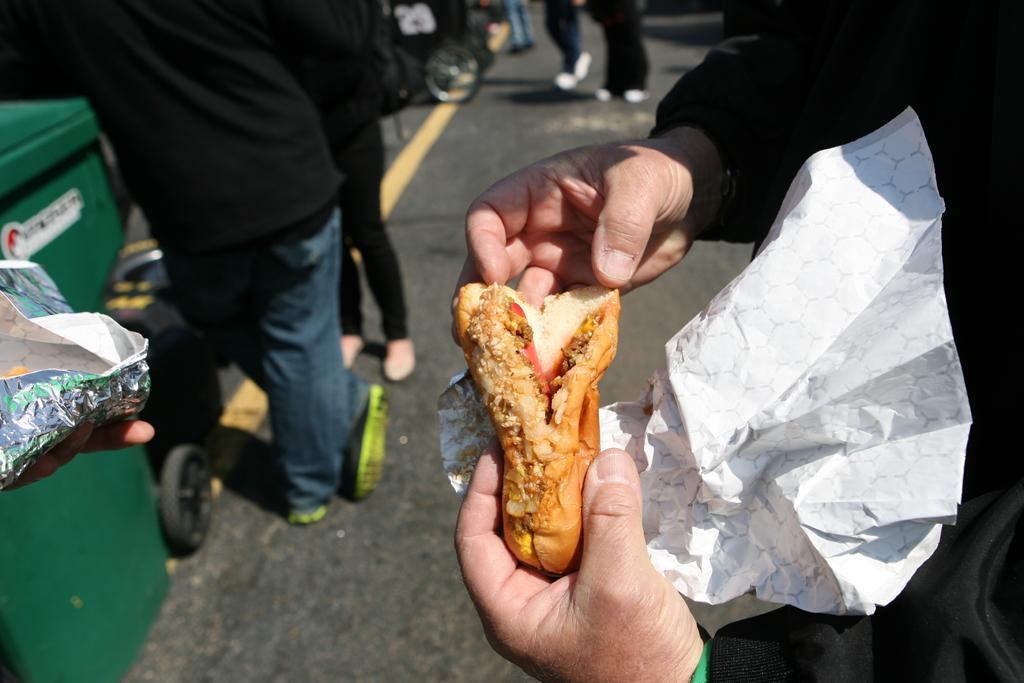How would you summarize this image in a sentence or two? In the picture we can see a person's hand holding some food item and in front of the person we can see a dustbin with wheels and beside it, we can see two people are standing and in the background we can see some people are walking and beside them we can see a vehicle wheel. 